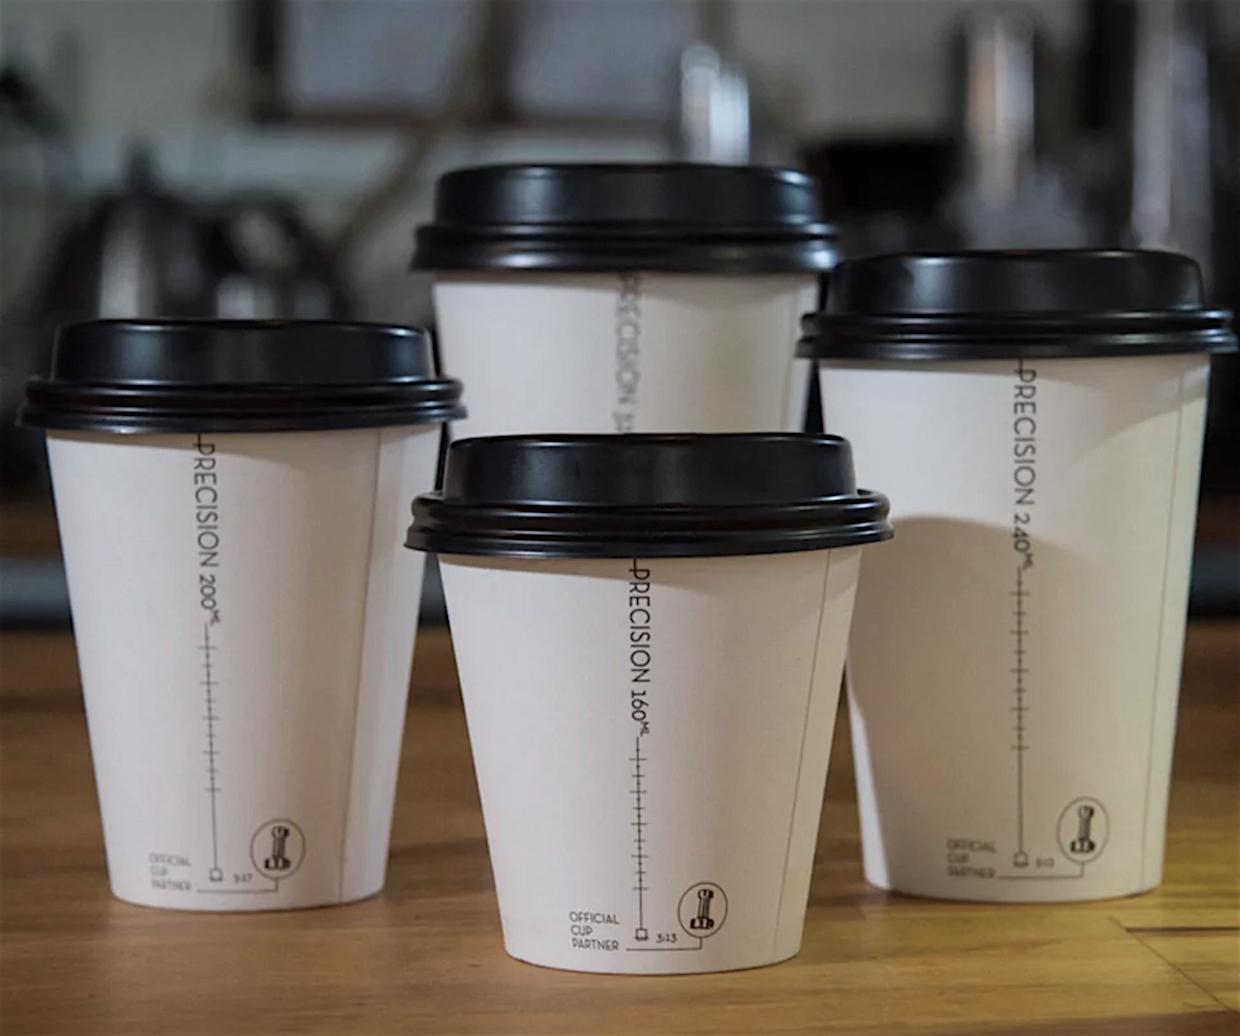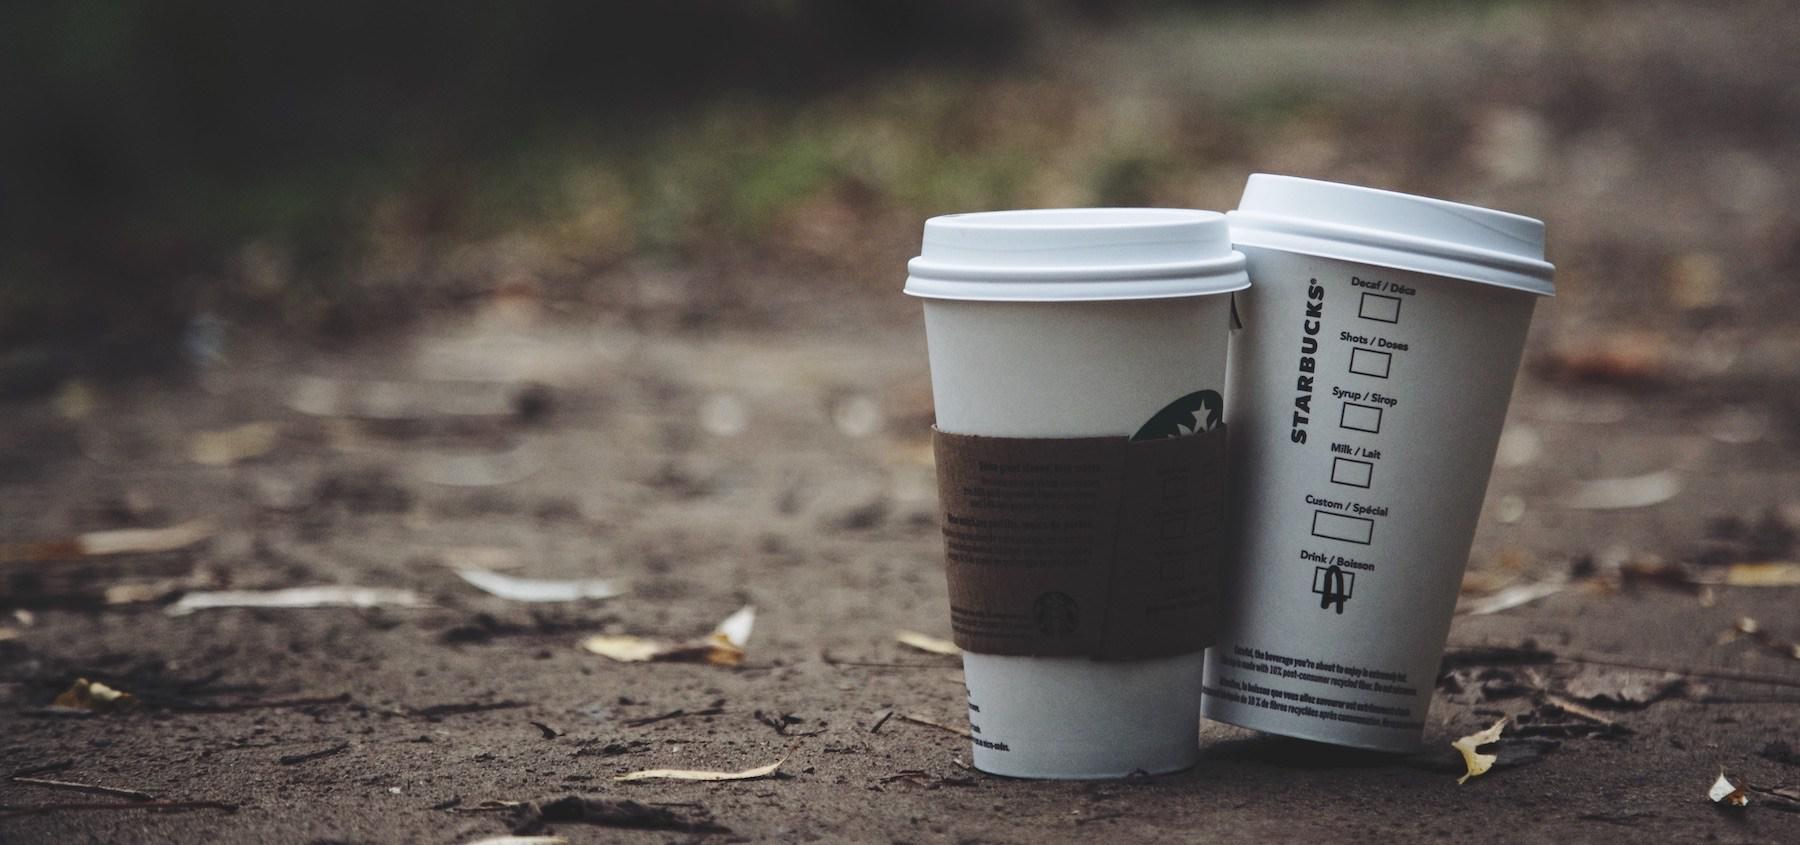The first image is the image on the left, the second image is the image on the right. Evaluate the accuracy of this statement regarding the images: "There are only two disposable coffee cups.". Is it true? Answer yes or no. No. The first image is the image on the left, the second image is the image on the right. Considering the images on both sides, is "There are exactly two cups." valid? Answer yes or no. No. 